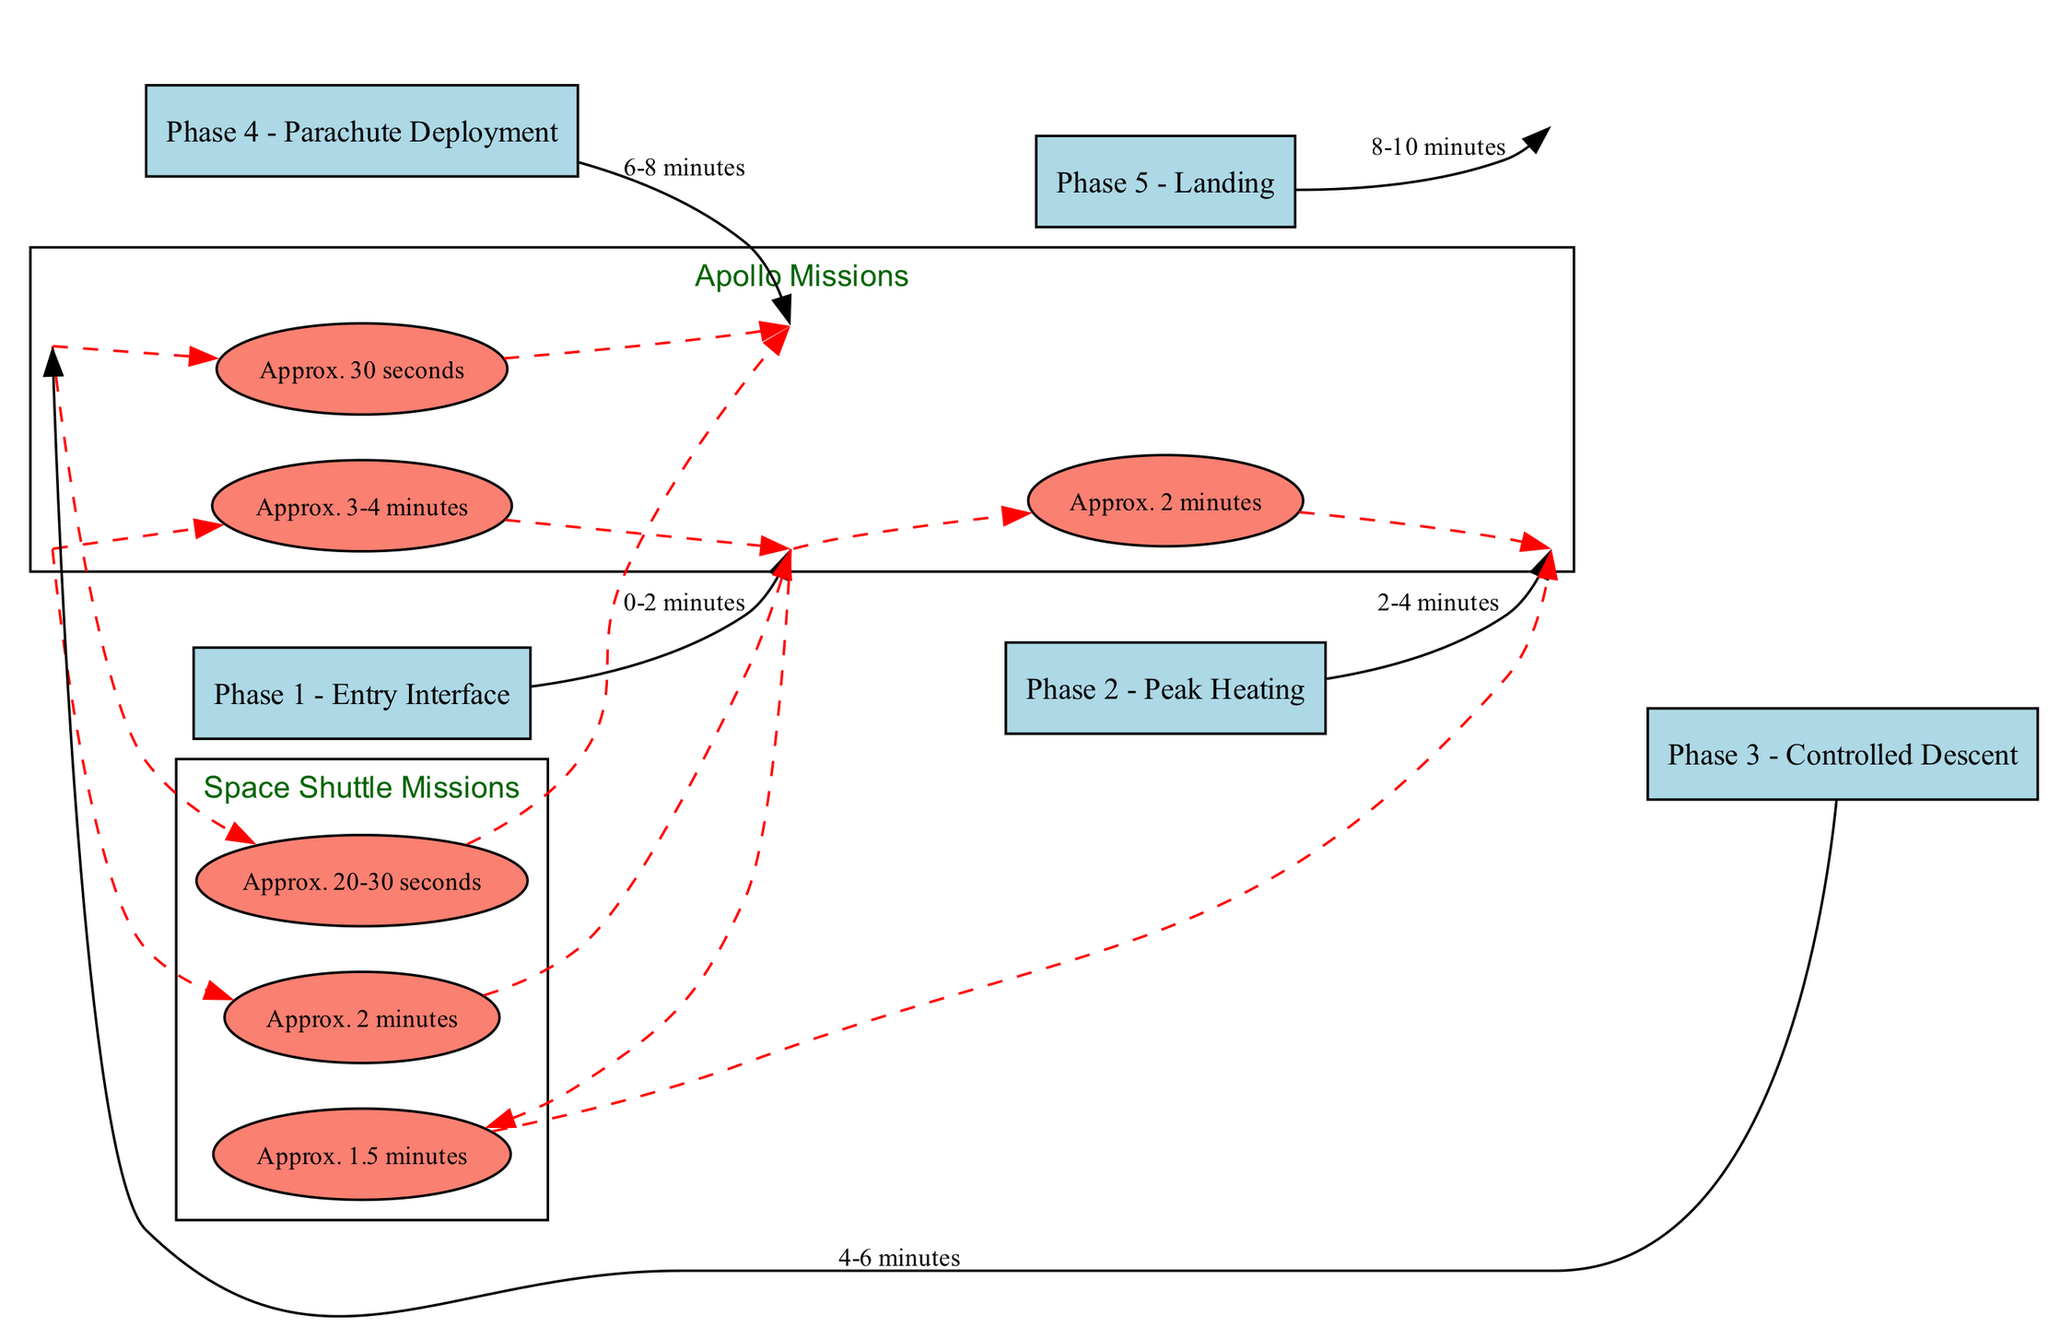What is the duration of Phase 1 - Entry Interface? The diagram states that the duration of Phase 1 - Entry Interface is from 0 to 2 minutes, as indicated in the phase description.
Answer: 0-2 minutes What is the blackout duration for the Apollo Missions during Phase 2 - Peak Heating? According to the timeline for Apollo Missions, the blackout duration during Phase 2 - Peak Heating is approximately 2 minutes.
Answer: Approx. 2 minutes How many phases are shown in the diagram? The diagram contains five phases related to communication blackout periods, as listed under the phases section.
Answer: 5 Which mission has a longer blackout duration in Phase 1 - Entry Interface? By comparing the blackout durations listed for the Apollo Missions (3-4 minutes) and Space Shuttle Missions (2 minutes) during Phase 1, it's clear that Apollo Missions have a longer blackout duration.
Answer: Apollo Missions Is there any blackout during Phase 3 - Controlled Descent? The data indicates that there is no blackout during this phase, as explicitly stated in both the phases and the mission timelines.
Answer: No blackout What is the color used for blackout duration nodes in the diagram? The blackout duration nodes are represented with an ellipse shape and filled with salmon color, as shown in the diagram's details.
Answer: Salmon During which phase does the brief blackout occur, according to the phases section? The brief blackout is indicated to occur during Phase 4 - Parachute Deployment as stated in the description of this phase.
Answer: Phase 4 - Parachute Deployment How does the blackout duration for Space Shuttle Missions in Phase 4 - Parachute Deployment compare to Apollo Missions? In Phase 4, Space Shuttle Missions have a blackout duration of approximately 20-30 seconds, while Apollo Missions have a longer blackout duration of about 30 seconds, indicating similarity but Apollo has a defined upper boundary.
Answer: Similar, Apollo longer In total, how many missions are analyzed in the diagram? The diagram analyzes two missions, Apollo Missions and Space Shuttle Missions, as detailed in the missions section.
Answer: 2 